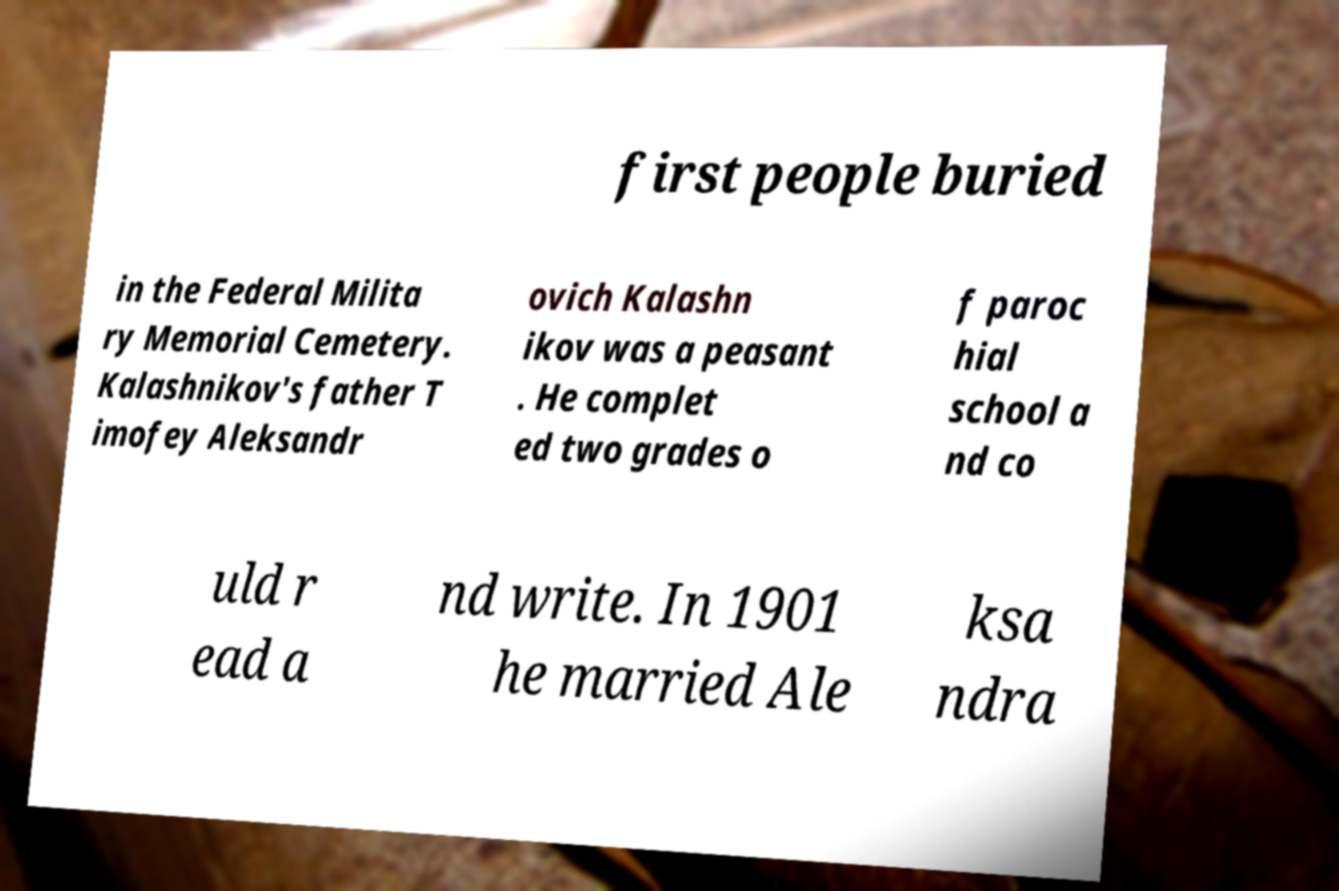Could you extract and type out the text from this image? first people buried in the Federal Milita ry Memorial Cemetery. Kalashnikov's father T imofey Aleksandr ovich Kalashn ikov was a peasant . He complet ed two grades o f paroc hial school a nd co uld r ead a nd write. In 1901 he married Ale ksa ndra 